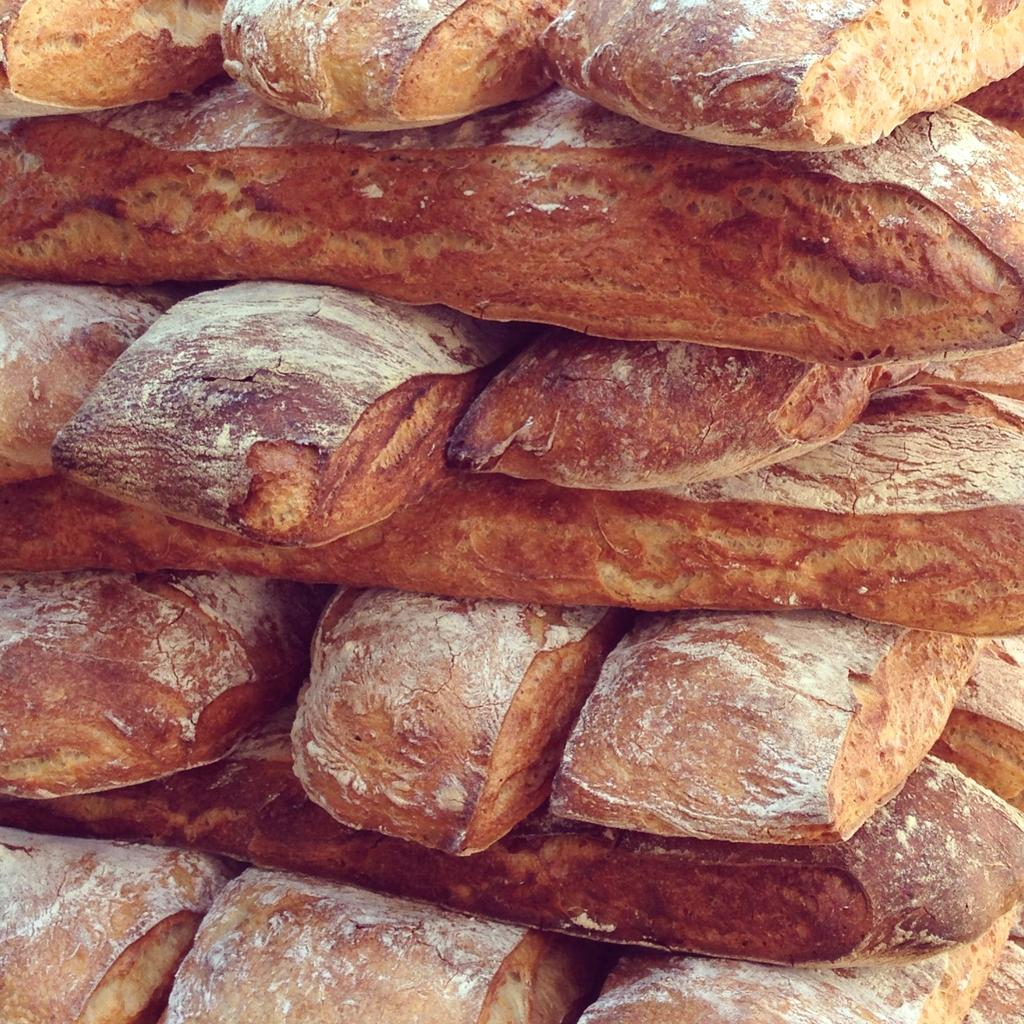What is the main subject of the image? The main subject of the image appears to resemble bread. Who is the owner of the trucks depicted in the image? There are no trucks present in the image, as it resembles bread. 